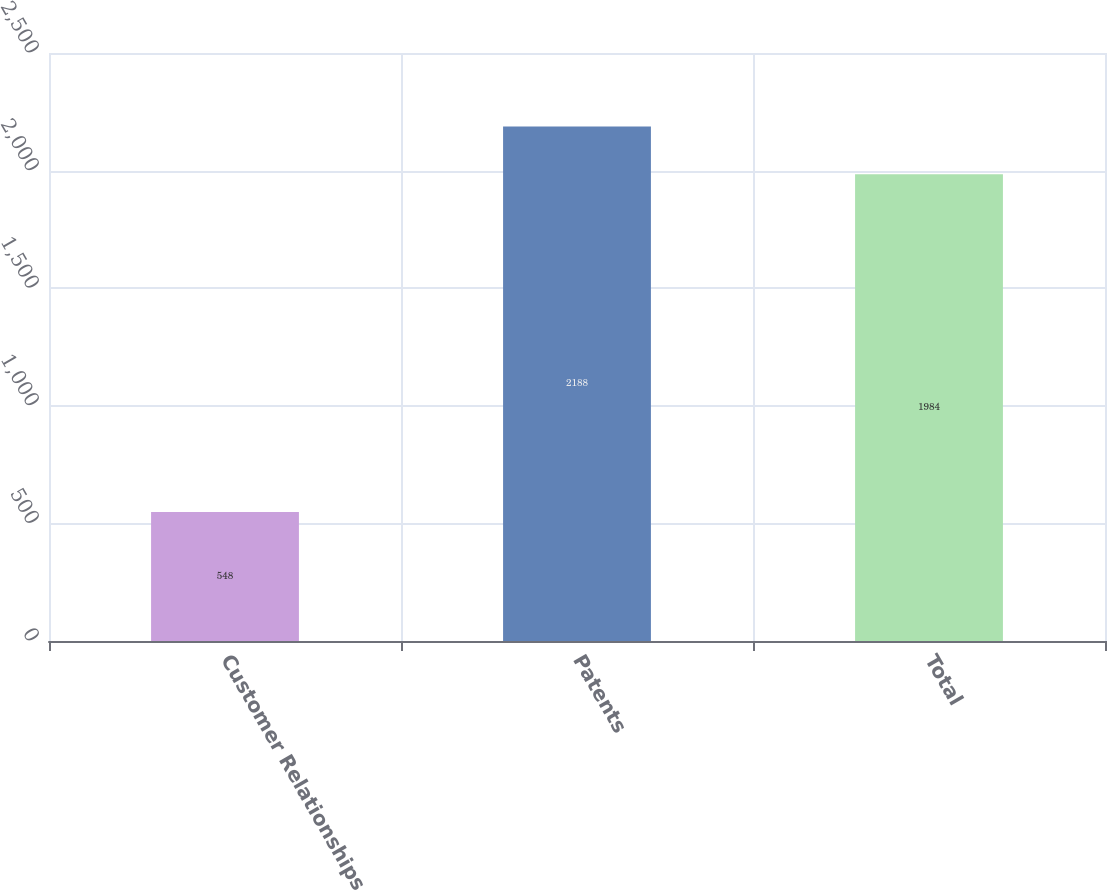Convert chart to OTSL. <chart><loc_0><loc_0><loc_500><loc_500><bar_chart><fcel>Customer Relationships<fcel>Patents<fcel>Total<nl><fcel>548<fcel>2188<fcel>1984<nl></chart> 